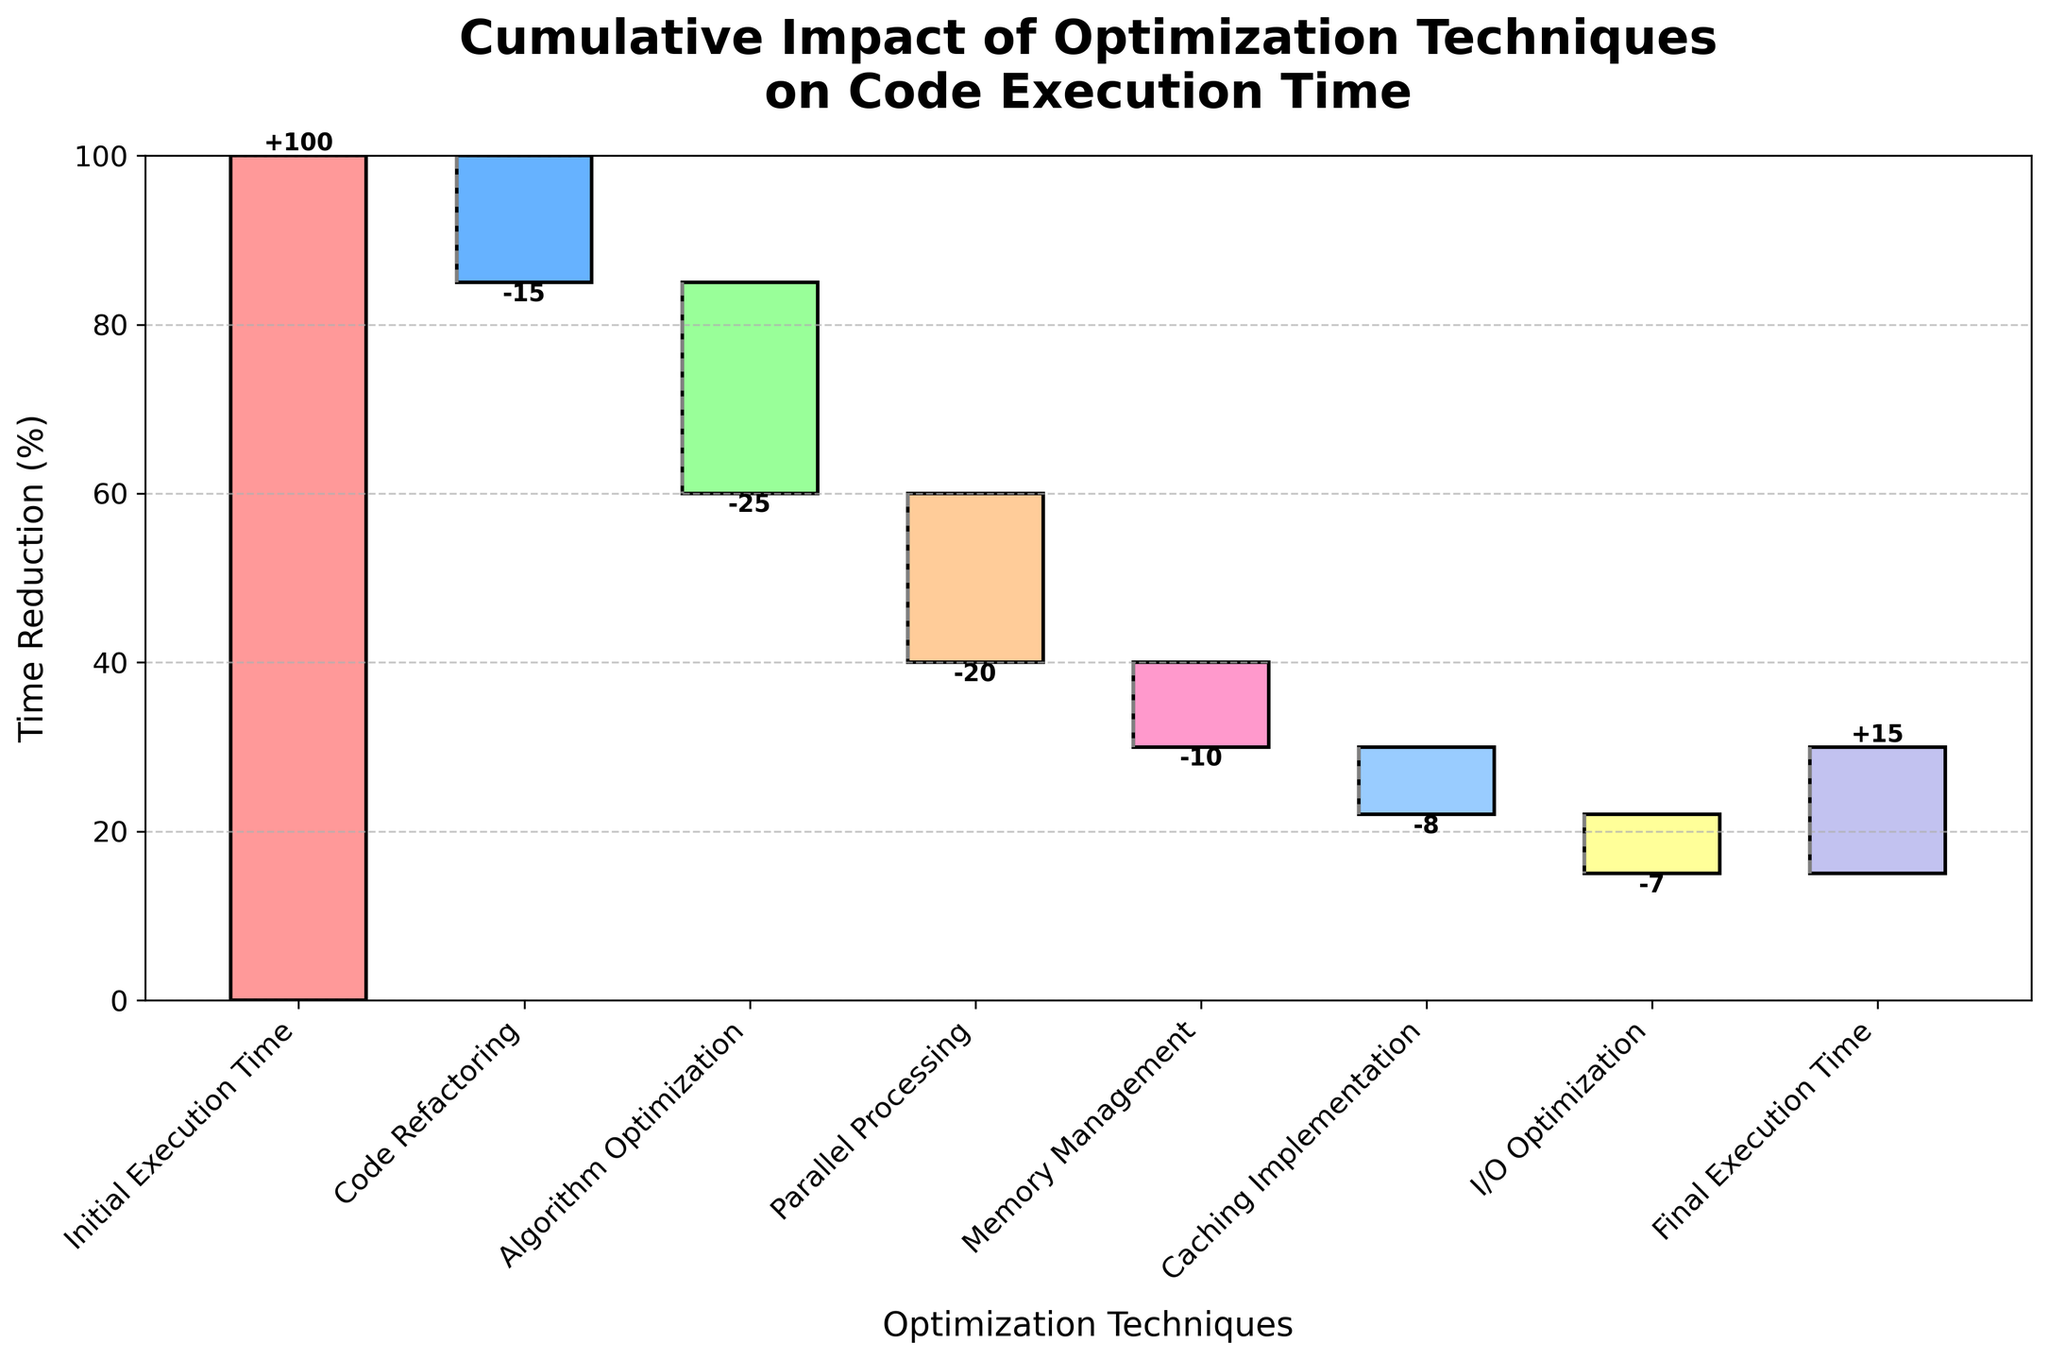What is the title of the chart? The title of the chart is usually located at the top and provides the main subject or summary of the chart. In this case, it specifically mentions the main subject.
Answer: Cumulative Impact of Optimization Techniques on Code Execution Time What is the initial execution time? To find the initial execution time, look at the first bar in the chart which represents the starting point.
Answer: 100 Which technique contributes the most to the time reduction? To determine this, look at the bars and identify the one that has the largest negative value, indicating the biggest reduction. In this case, it's the bar with the largest decrease in height downward.
Answer: Algorithm Optimization What color is used for Memory Management in the chart? Look at the segments of the bars and identify the color corresponding to the labeled technique 'Memory Management'.
Answer: #FF99CC (Pink) What is the final execution time after all optimizations? Look at the last label on the x-axis and identify the corresponding value for the final execution time.
Answer: 15 What's the cumulative time reduction after applying Code Refactoring and Algorithm Optimization? First, identify the individual reductions for Code Refactoring and Algorithm Optimization. Sum these values to get the cumulative reduction.
Answer: -40 By how much did Parallel Processing improve the execution time? Locate the value directly associated with Parallel Processing, and note the negative reduction which indicates the improvement.
Answer: -20 Which optimization technique has the smallest impact on code execution time? Compare the values of all techniques and identify the one with the smallest absolute value, representing the least impact.
Answer: I/O Optimization How much total time was saved by all the optimization techniques together? Sum all the negative values of the techniques applied (excluding the initial and final execution times) to calculate the total time saved.
Answer: -85 What's the difference in execution time after Memory Management compared to after Algorithm Optimization? Find the cumulative execution time values after Memory Management and Algorithm Optimization, then subtract the latter from the former to find the difference.
Answer: 30 